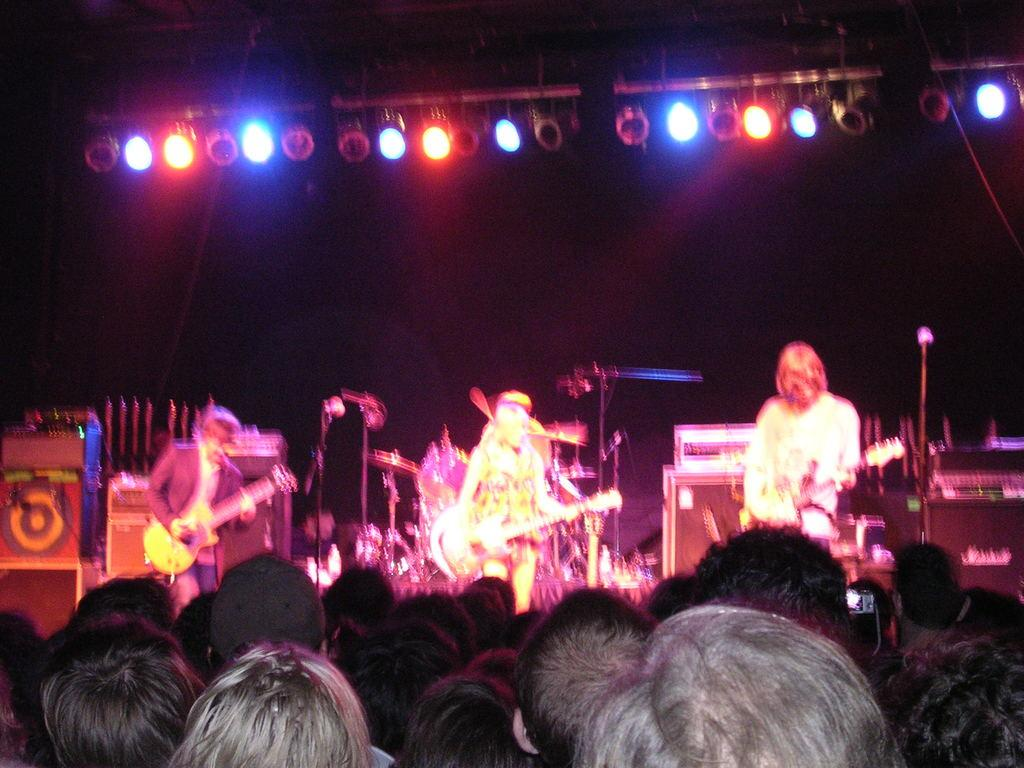What are the people in the image doing? The people in the image are playing musical instruments. What are the people wearing while playing the instruments? The people are wearing colorful dresses. What can be seen in the background of the image? There are lights visible in the background of the image. Can you tell me how many matches the people are holding in the image? There are no matches present in the image; the people are playing musical instruments. What time of day is it in the image? The provided facts do not specify the time of day, so it cannot be determined from the image. 